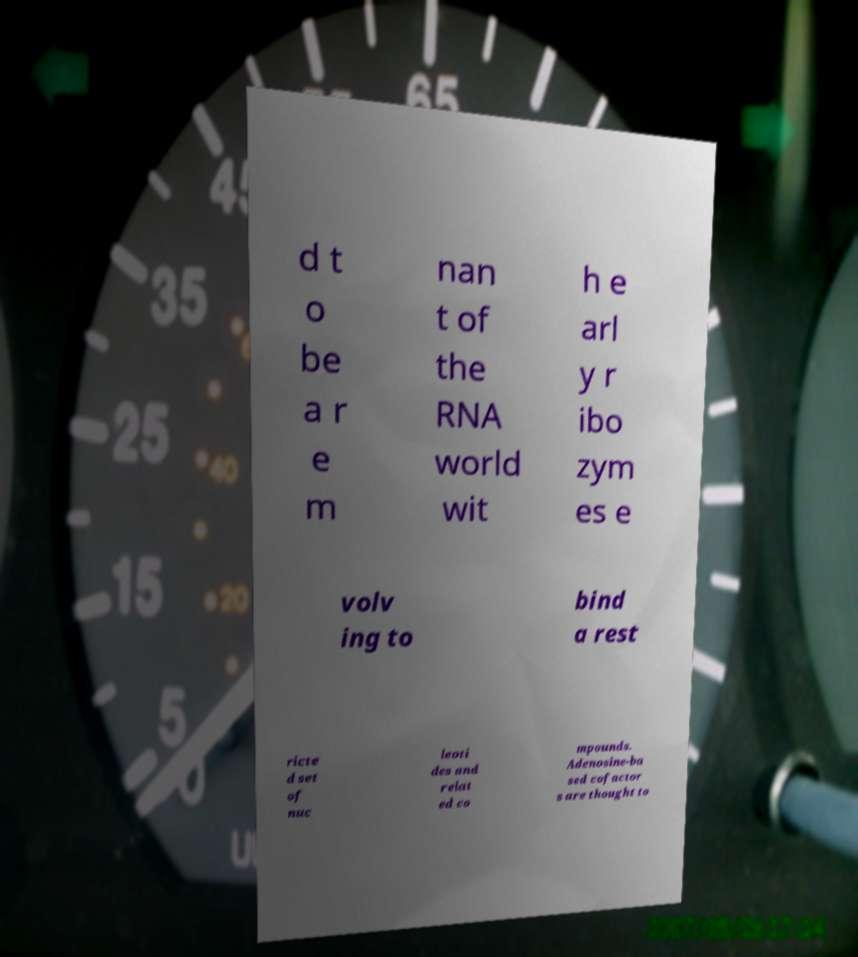Could you assist in decoding the text presented in this image and type it out clearly? d t o be a r e m nan t of the RNA world wit h e arl y r ibo zym es e volv ing to bind a rest ricte d set of nuc leoti des and relat ed co mpounds. Adenosine-ba sed cofactor s are thought to 